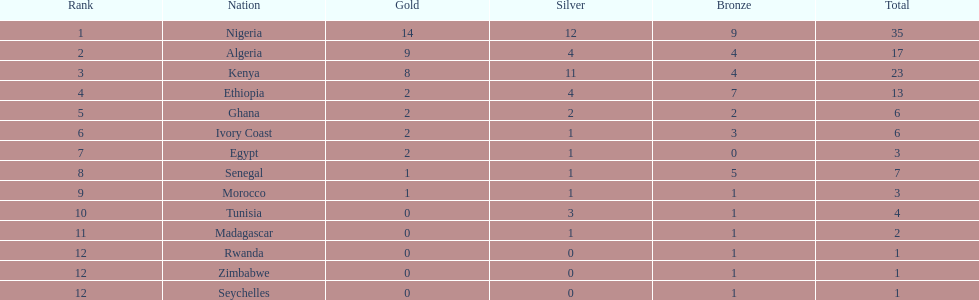On this chart, which nation appears first in the list? Nigeria. 